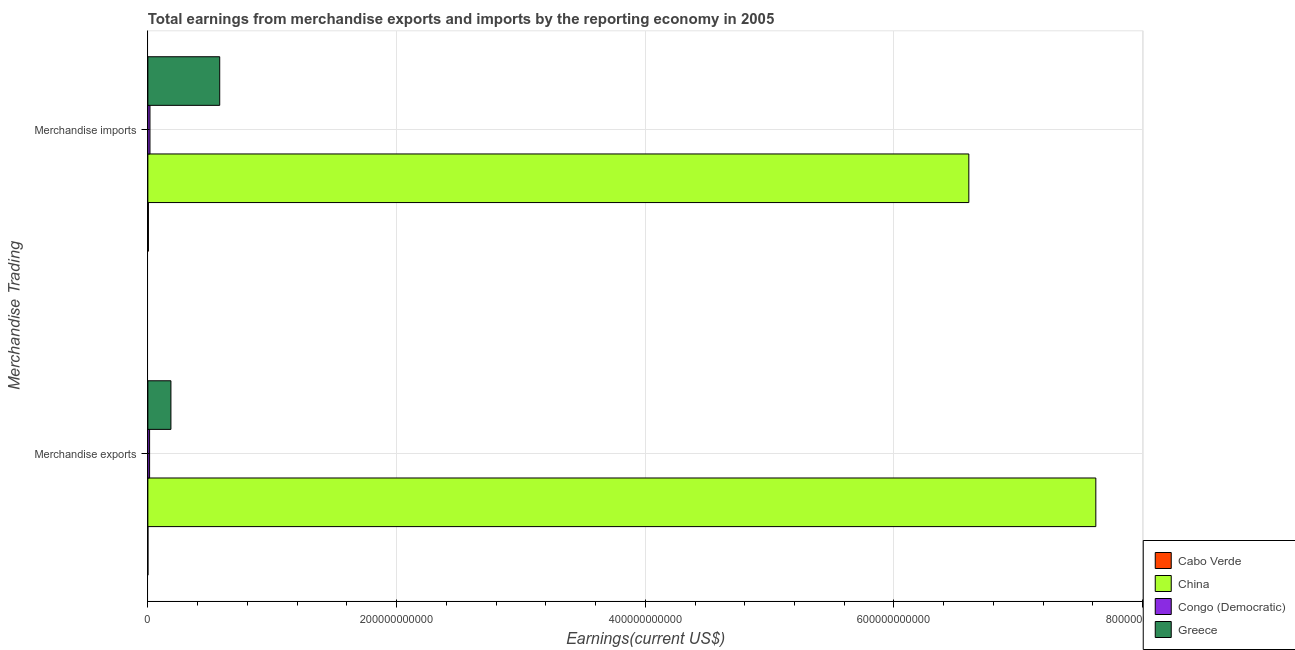How many different coloured bars are there?
Provide a short and direct response. 4. How many groups of bars are there?
Provide a short and direct response. 2. What is the label of the 1st group of bars from the top?
Give a very brief answer. Merchandise imports. What is the earnings from merchandise exports in China?
Your answer should be compact. 7.62e+11. Across all countries, what is the maximum earnings from merchandise exports?
Offer a very short reply. 7.62e+11. Across all countries, what is the minimum earnings from merchandise exports?
Your answer should be compact. 1.77e+07. In which country was the earnings from merchandise imports maximum?
Your response must be concise. China. In which country was the earnings from merchandise exports minimum?
Ensure brevity in your answer.  Cabo Verde. What is the total earnings from merchandise imports in the graph?
Keep it short and to the point. 7.20e+11. What is the difference between the earnings from merchandise exports in Greece and that in Cabo Verde?
Offer a very short reply. 1.85e+1. What is the difference between the earnings from merchandise imports in Greece and the earnings from merchandise exports in Congo (Democratic)?
Give a very brief answer. 5.64e+1. What is the average earnings from merchandise exports per country?
Ensure brevity in your answer.  1.96e+11. What is the difference between the earnings from merchandise exports and earnings from merchandise imports in China?
Keep it short and to the point. 1.02e+11. What is the ratio of the earnings from merchandise imports in Congo (Democratic) to that in China?
Make the answer very short. 0. Is the earnings from merchandise imports in Greece less than that in China?
Keep it short and to the point. Yes. What does the 1st bar from the top in Merchandise exports represents?
Your response must be concise. Greece. What does the 4th bar from the bottom in Merchandise exports represents?
Your response must be concise. Greece. How many countries are there in the graph?
Offer a very short reply. 4. What is the difference between two consecutive major ticks on the X-axis?
Make the answer very short. 2.00e+11. Does the graph contain any zero values?
Your answer should be compact. No. Does the graph contain grids?
Keep it short and to the point. Yes. What is the title of the graph?
Provide a short and direct response. Total earnings from merchandise exports and imports by the reporting economy in 2005. What is the label or title of the X-axis?
Provide a short and direct response. Earnings(current US$). What is the label or title of the Y-axis?
Offer a terse response. Merchandise Trading. What is the Earnings(current US$) in Cabo Verde in Merchandise exports?
Make the answer very short. 1.77e+07. What is the Earnings(current US$) in China in Merchandise exports?
Provide a succinct answer. 7.62e+11. What is the Earnings(current US$) in Congo (Democratic) in Merchandise exports?
Offer a very short reply. 1.38e+09. What is the Earnings(current US$) in Greece in Merchandise exports?
Offer a terse response. 1.85e+1. What is the Earnings(current US$) of Cabo Verde in Merchandise imports?
Your answer should be very brief. 4.32e+08. What is the Earnings(current US$) of China in Merchandise imports?
Make the answer very short. 6.60e+11. What is the Earnings(current US$) in Congo (Democratic) in Merchandise imports?
Give a very brief answer. 1.69e+09. What is the Earnings(current US$) in Greece in Merchandise imports?
Keep it short and to the point. 5.78e+1. Across all Merchandise Trading, what is the maximum Earnings(current US$) in Cabo Verde?
Your answer should be compact. 4.32e+08. Across all Merchandise Trading, what is the maximum Earnings(current US$) of China?
Give a very brief answer. 7.62e+11. Across all Merchandise Trading, what is the maximum Earnings(current US$) of Congo (Democratic)?
Offer a terse response. 1.69e+09. Across all Merchandise Trading, what is the maximum Earnings(current US$) in Greece?
Keep it short and to the point. 5.78e+1. Across all Merchandise Trading, what is the minimum Earnings(current US$) in Cabo Verde?
Ensure brevity in your answer.  1.77e+07. Across all Merchandise Trading, what is the minimum Earnings(current US$) of China?
Your answer should be very brief. 6.60e+11. Across all Merchandise Trading, what is the minimum Earnings(current US$) in Congo (Democratic)?
Offer a very short reply. 1.38e+09. Across all Merchandise Trading, what is the minimum Earnings(current US$) in Greece?
Offer a terse response. 1.85e+1. What is the total Earnings(current US$) of Cabo Verde in the graph?
Provide a succinct answer. 4.50e+08. What is the total Earnings(current US$) in China in the graph?
Provide a short and direct response. 1.42e+12. What is the total Earnings(current US$) of Congo (Democratic) in the graph?
Your answer should be very brief. 3.07e+09. What is the total Earnings(current US$) of Greece in the graph?
Your answer should be compact. 7.63e+1. What is the difference between the Earnings(current US$) of Cabo Verde in Merchandise exports and that in Merchandise imports?
Provide a succinct answer. -4.15e+08. What is the difference between the Earnings(current US$) in China in Merchandise exports and that in Merchandise imports?
Offer a very short reply. 1.02e+11. What is the difference between the Earnings(current US$) of Congo (Democratic) in Merchandise exports and that in Merchandise imports?
Provide a short and direct response. -3.05e+08. What is the difference between the Earnings(current US$) in Greece in Merchandise exports and that in Merchandise imports?
Give a very brief answer. -3.92e+1. What is the difference between the Earnings(current US$) in Cabo Verde in Merchandise exports and the Earnings(current US$) in China in Merchandise imports?
Ensure brevity in your answer.  -6.60e+11. What is the difference between the Earnings(current US$) in Cabo Verde in Merchandise exports and the Earnings(current US$) in Congo (Democratic) in Merchandise imports?
Offer a terse response. -1.67e+09. What is the difference between the Earnings(current US$) in Cabo Verde in Merchandise exports and the Earnings(current US$) in Greece in Merchandise imports?
Give a very brief answer. -5.78e+1. What is the difference between the Earnings(current US$) in China in Merchandise exports and the Earnings(current US$) in Congo (Democratic) in Merchandise imports?
Give a very brief answer. 7.61e+11. What is the difference between the Earnings(current US$) in China in Merchandise exports and the Earnings(current US$) in Greece in Merchandise imports?
Your answer should be compact. 7.05e+11. What is the difference between the Earnings(current US$) of Congo (Democratic) in Merchandise exports and the Earnings(current US$) of Greece in Merchandise imports?
Provide a succinct answer. -5.64e+1. What is the average Earnings(current US$) of Cabo Verde per Merchandise Trading?
Provide a succinct answer. 2.25e+08. What is the average Earnings(current US$) in China per Merchandise Trading?
Offer a terse response. 7.11e+11. What is the average Earnings(current US$) in Congo (Democratic) per Merchandise Trading?
Keep it short and to the point. 1.53e+09. What is the average Earnings(current US$) in Greece per Merchandise Trading?
Offer a very short reply. 3.82e+1. What is the difference between the Earnings(current US$) of Cabo Verde and Earnings(current US$) of China in Merchandise exports?
Your answer should be very brief. -7.62e+11. What is the difference between the Earnings(current US$) of Cabo Verde and Earnings(current US$) of Congo (Democratic) in Merchandise exports?
Provide a succinct answer. -1.36e+09. What is the difference between the Earnings(current US$) in Cabo Verde and Earnings(current US$) in Greece in Merchandise exports?
Offer a very short reply. -1.85e+1. What is the difference between the Earnings(current US$) in China and Earnings(current US$) in Congo (Democratic) in Merchandise exports?
Offer a terse response. 7.61e+11. What is the difference between the Earnings(current US$) in China and Earnings(current US$) in Greece in Merchandise exports?
Offer a terse response. 7.44e+11. What is the difference between the Earnings(current US$) in Congo (Democratic) and Earnings(current US$) in Greece in Merchandise exports?
Make the answer very short. -1.72e+1. What is the difference between the Earnings(current US$) in Cabo Verde and Earnings(current US$) in China in Merchandise imports?
Offer a terse response. -6.60e+11. What is the difference between the Earnings(current US$) of Cabo Verde and Earnings(current US$) of Congo (Democratic) in Merchandise imports?
Offer a terse response. -1.25e+09. What is the difference between the Earnings(current US$) of Cabo Verde and Earnings(current US$) of Greece in Merchandise imports?
Provide a succinct answer. -5.74e+1. What is the difference between the Earnings(current US$) in China and Earnings(current US$) in Congo (Democratic) in Merchandise imports?
Offer a terse response. 6.59e+11. What is the difference between the Earnings(current US$) in China and Earnings(current US$) in Greece in Merchandise imports?
Provide a succinct answer. 6.02e+11. What is the difference between the Earnings(current US$) in Congo (Democratic) and Earnings(current US$) in Greece in Merchandise imports?
Make the answer very short. -5.61e+1. What is the ratio of the Earnings(current US$) in Cabo Verde in Merchandise exports to that in Merchandise imports?
Offer a terse response. 0.04. What is the ratio of the Earnings(current US$) of China in Merchandise exports to that in Merchandise imports?
Ensure brevity in your answer.  1.15. What is the ratio of the Earnings(current US$) in Congo (Democratic) in Merchandise exports to that in Merchandise imports?
Keep it short and to the point. 0.82. What is the ratio of the Earnings(current US$) in Greece in Merchandise exports to that in Merchandise imports?
Ensure brevity in your answer.  0.32. What is the difference between the highest and the second highest Earnings(current US$) in Cabo Verde?
Your response must be concise. 4.15e+08. What is the difference between the highest and the second highest Earnings(current US$) of China?
Give a very brief answer. 1.02e+11. What is the difference between the highest and the second highest Earnings(current US$) of Congo (Democratic)?
Your response must be concise. 3.05e+08. What is the difference between the highest and the second highest Earnings(current US$) in Greece?
Provide a succinct answer. 3.92e+1. What is the difference between the highest and the lowest Earnings(current US$) in Cabo Verde?
Your answer should be very brief. 4.15e+08. What is the difference between the highest and the lowest Earnings(current US$) of China?
Keep it short and to the point. 1.02e+11. What is the difference between the highest and the lowest Earnings(current US$) in Congo (Democratic)?
Your answer should be very brief. 3.05e+08. What is the difference between the highest and the lowest Earnings(current US$) of Greece?
Offer a very short reply. 3.92e+1. 